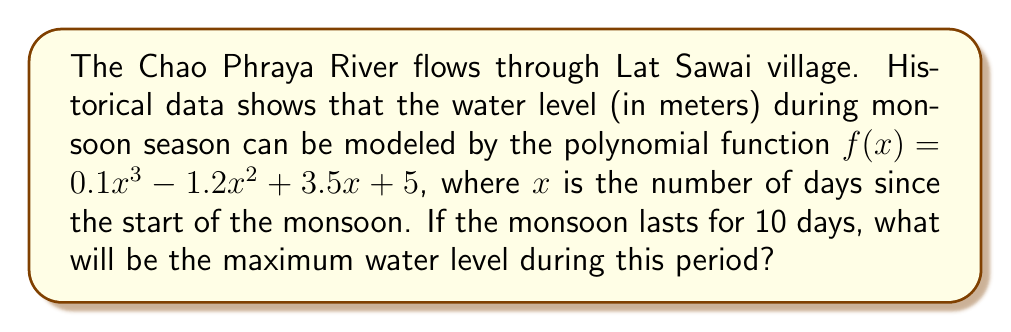Provide a solution to this math problem. To find the maximum water level, we need to follow these steps:

1) The polynomial function given is: $f(x) = 0.1x^3 - 1.2x^2 + 3.5x + 5$

2) To find the maximum, we need to find the critical points by taking the derivative and setting it to zero:
   $f'(x) = 0.3x^2 - 2.4x + 3.5$

3) Set $f'(x) = 0$:
   $0.3x^2 - 2.4x + 3.5 = 0$

4) This is a quadratic equation. We can solve it using the quadratic formula:
   $x = \frac{-b \pm \sqrt{b^2 - 4ac}}{2a}$

   Where $a = 0.3$, $b = -2.4$, and $c = 3.5$

5) Plugging in these values:
   $x = \frac{2.4 \pm \sqrt{(-2.4)^2 - 4(0.3)(3.5)}}{2(0.3)}$
   $= \frac{2.4 \pm \sqrt{5.76 - 4.2}}{0.6}$
   $= \frac{2.4 \pm \sqrt{1.56}}{0.6}$
   $= \frac{2.4 \pm 1.25}{0.6}$

6) This gives us two critical points:
   $x_1 = \frac{2.4 + 1.25}{0.6} = 6.08$
   $x_2 = \frac{2.4 - 1.25}{0.6} = 1.92$

7) Since the monsoon lasts for 10 days, we need to check the water level at $x = 0$, $x = 6.08$, $x = 10$, and $x = 1.92$:

   At $x = 0$: $f(0) = 5$
   At $x = 1.92$: $f(1.92) \approx 8.15$
   At $x = 6.08$: $f(6.08) \approx 11.84$
   At $x = 10$: $f(10) = 10$

8) The maximum of these values is 11.84, which occurs at $x = 6.08$.

Therefore, the maximum water level during the 10-day monsoon period will be approximately 11.84 meters.
Answer: 11.84 meters 